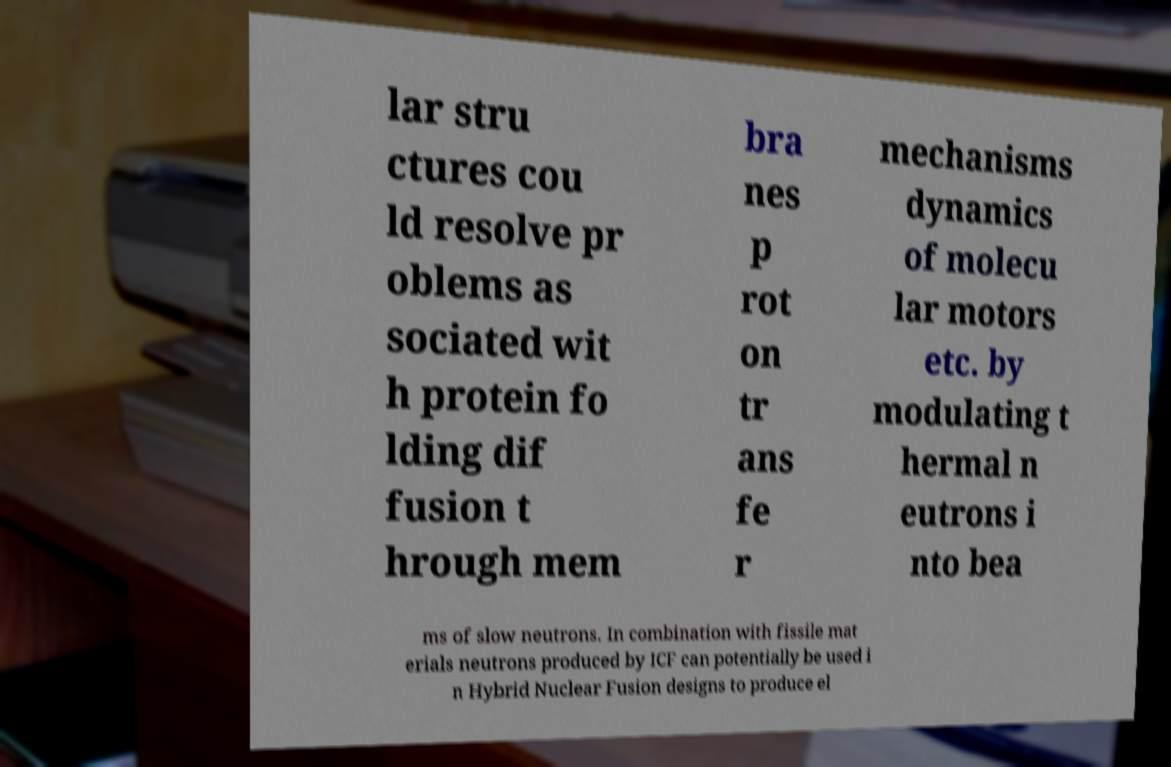Can you accurately transcribe the text from the provided image for me? lar stru ctures cou ld resolve pr oblems as sociated wit h protein fo lding dif fusion t hrough mem bra nes p rot on tr ans fe r mechanisms dynamics of molecu lar motors etc. by modulating t hermal n eutrons i nto bea ms of slow neutrons. In combination with fissile mat erials neutrons produced by ICF can potentially be used i n Hybrid Nuclear Fusion designs to produce el 